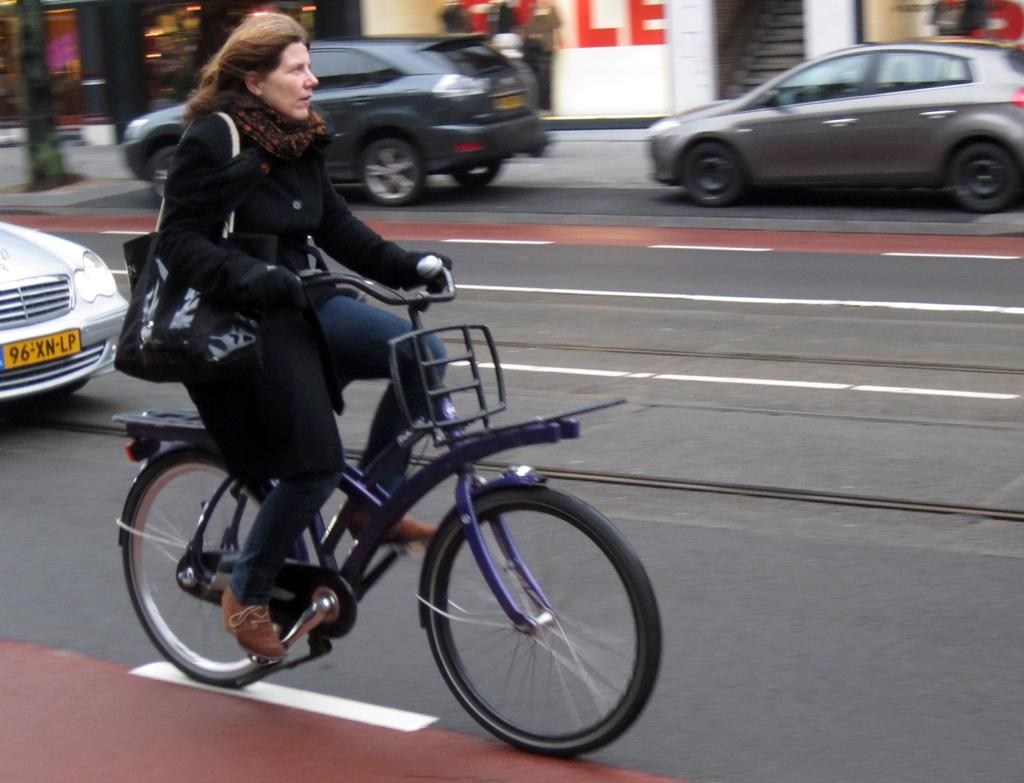What type of clothing is the woman wearing on her upper body in the image? The woman is wearing a black jacket in the image. What accessory is the woman wearing around her neck? The woman is wearing a scarf in the image. What is the woman carrying while riding the bicycle? The woman is carrying a bag in the image. What mode of transportation is the woman using? The woman is riding a bicycle in the image. What can be seen on the road in the image? There are cars on the road in the image. What type of structures are visible in the background? There are buildings visible in the image. What architectural feature can be seen in the image? There is a staircase in the image. What type of nut can be seen in the image? There are no nuts present in the image. 